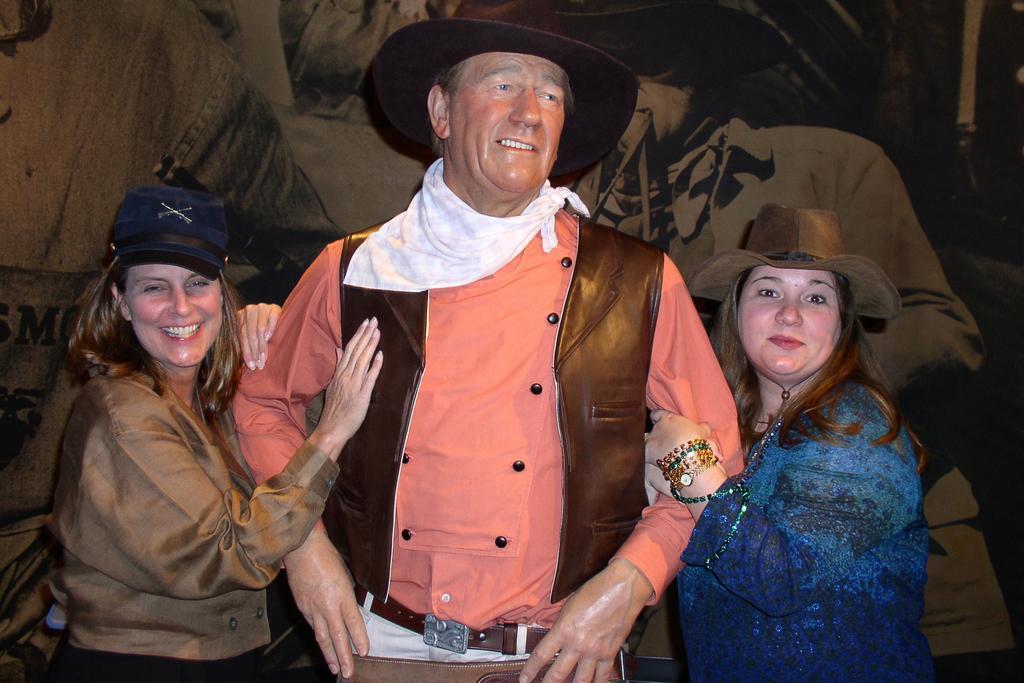Describe this image in one or two sentences. In the picture we can see a man standing and wearing a hat and both the sides of the man we can see the women standing and holding the hands of a man and they are smiling and behind them we can see a wall with some designs on it. 